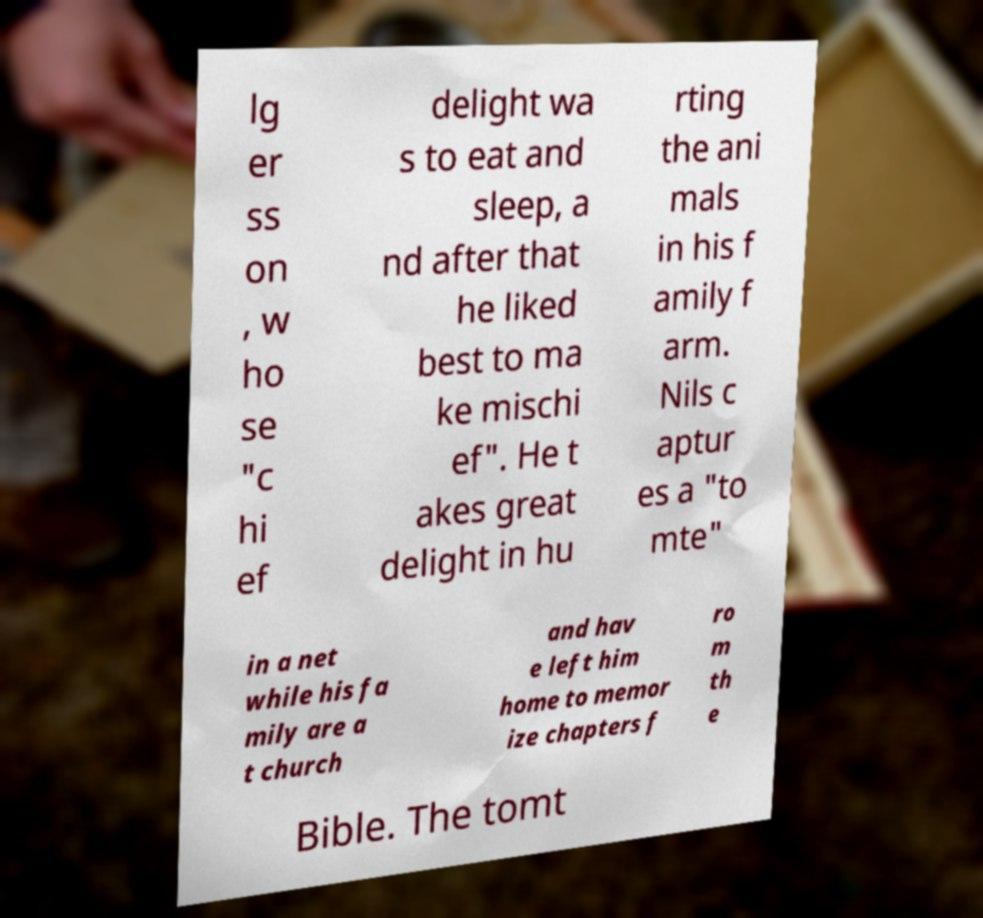Can you accurately transcribe the text from the provided image for me? lg er ss on , w ho se "c hi ef delight wa s to eat and sleep, a nd after that he liked best to ma ke mischi ef". He t akes great delight in hu rting the ani mals in his f amily f arm. Nils c aptur es a "to mte" in a net while his fa mily are a t church and hav e left him home to memor ize chapters f ro m th e Bible. The tomt 